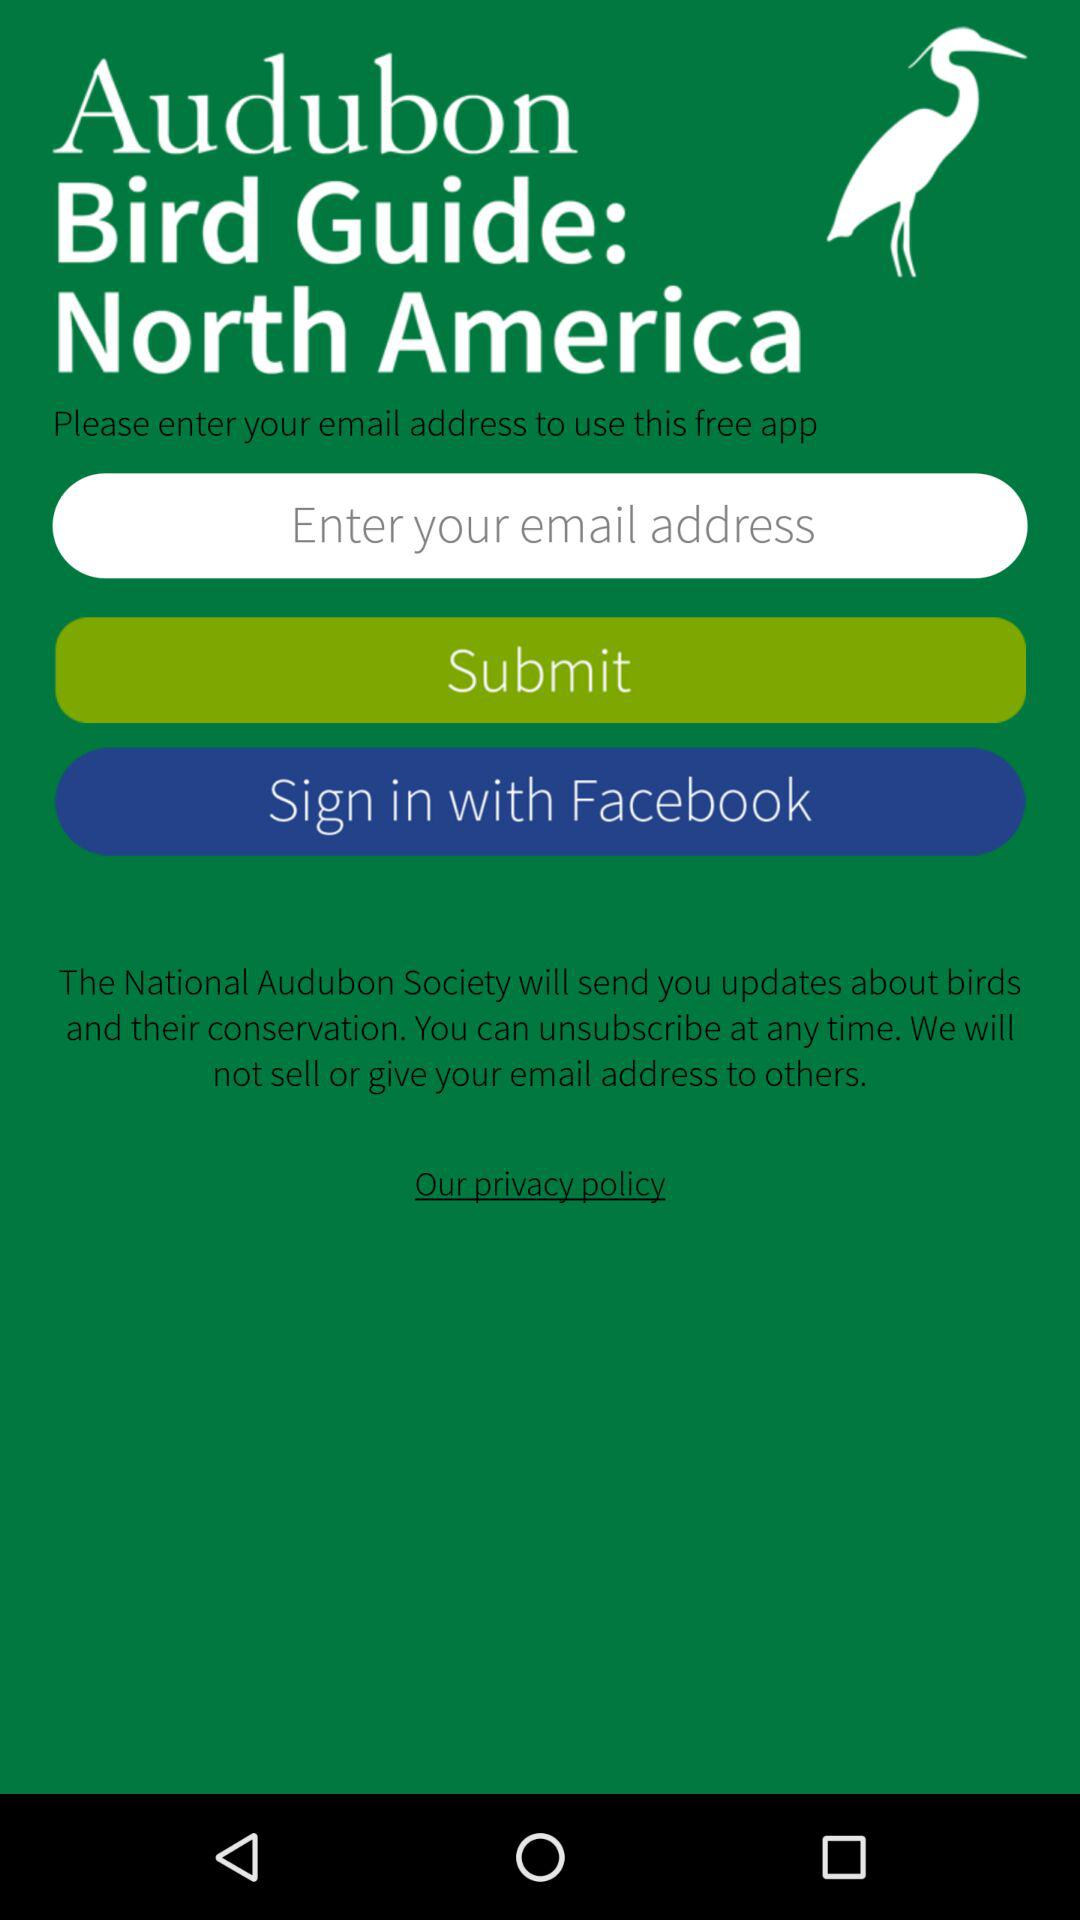What application can be used to sign in? You can sign in with your "email address" and "Facebook". 